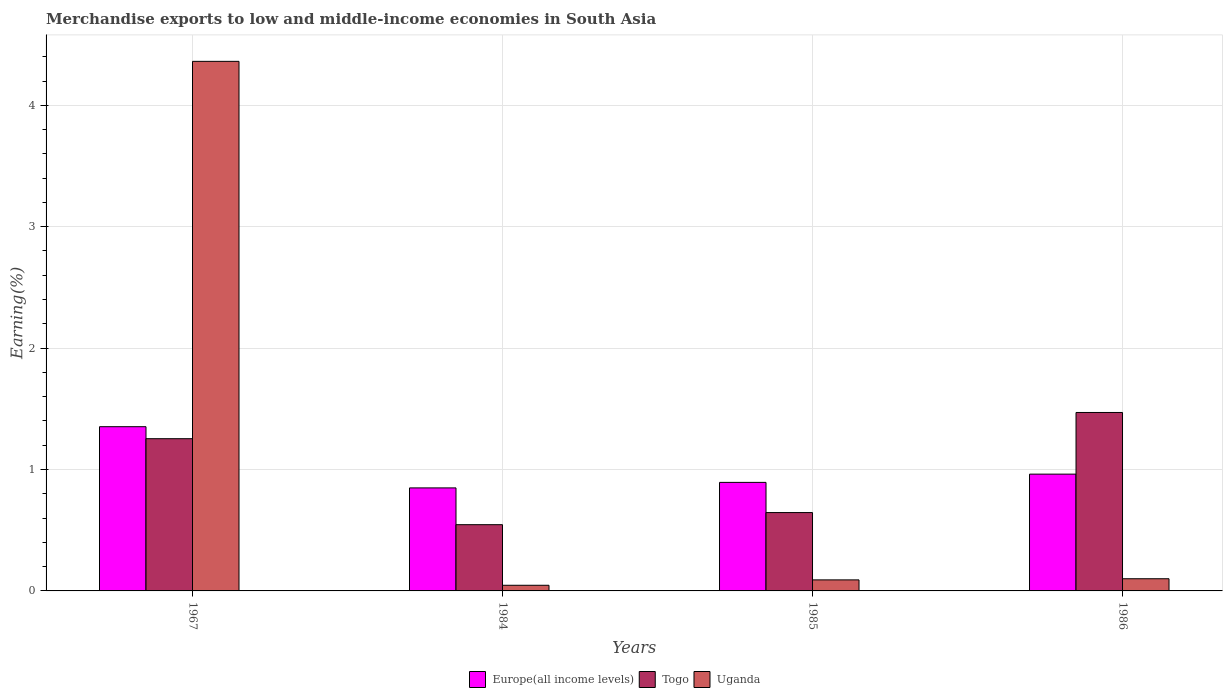How many different coloured bars are there?
Your response must be concise. 3. Are the number of bars on each tick of the X-axis equal?
Ensure brevity in your answer.  Yes. How many bars are there on the 1st tick from the right?
Provide a succinct answer. 3. What is the label of the 4th group of bars from the left?
Offer a very short reply. 1986. What is the percentage of amount earned from merchandise exports in Uganda in 1967?
Offer a terse response. 4.36. Across all years, what is the maximum percentage of amount earned from merchandise exports in Europe(all income levels)?
Offer a terse response. 1.35. Across all years, what is the minimum percentage of amount earned from merchandise exports in Europe(all income levels)?
Your answer should be very brief. 0.85. In which year was the percentage of amount earned from merchandise exports in Uganda maximum?
Your response must be concise. 1967. In which year was the percentage of amount earned from merchandise exports in Togo minimum?
Ensure brevity in your answer.  1984. What is the total percentage of amount earned from merchandise exports in Uganda in the graph?
Provide a succinct answer. 4.6. What is the difference between the percentage of amount earned from merchandise exports in Uganda in 1984 and that in 1986?
Give a very brief answer. -0.05. What is the difference between the percentage of amount earned from merchandise exports in Europe(all income levels) in 1986 and the percentage of amount earned from merchandise exports in Uganda in 1984?
Your answer should be compact. 0.92. What is the average percentage of amount earned from merchandise exports in Europe(all income levels) per year?
Offer a very short reply. 1.01. In the year 1967, what is the difference between the percentage of amount earned from merchandise exports in Togo and percentage of amount earned from merchandise exports in Europe(all income levels)?
Your response must be concise. -0.1. What is the ratio of the percentage of amount earned from merchandise exports in Uganda in 1984 to that in 1985?
Your answer should be very brief. 0.51. Is the percentage of amount earned from merchandise exports in Europe(all income levels) in 1967 less than that in 1985?
Keep it short and to the point. No. What is the difference between the highest and the second highest percentage of amount earned from merchandise exports in Uganda?
Provide a short and direct response. 4.26. What is the difference between the highest and the lowest percentage of amount earned from merchandise exports in Uganda?
Keep it short and to the point. 4.32. What does the 3rd bar from the left in 1967 represents?
Provide a succinct answer. Uganda. What does the 1st bar from the right in 1984 represents?
Offer a very short reply. Uganda. How many bars are there?
Provide a succinct answer. 12. Are all the bars in the graph horizontal?
Offer a very short reply. No. What is the difference between two consecutive major ticks on the Y-axis?
Keep it short and to the point. 1. Are the values on the major ticks of Y-axis written in scientific E-notation?
Your answer should be compact. No. Does the graph contain grids?
Keep it short and to the point. Yes. How many legend labels are there?
Make the answer very short. 3. What is the title of the graph?
Your answer should be compact. Merchandise exports to low and middle-income economies in South Asia. Does "Cameroon" appear as one of the legend labels in the graph?
Ensure brevity in your answer.  No. What is the label or title of the X-axis?
Offer a terse response. Years. What is the label or title of the Y-axis?
Give a very brief answer. Earning(%). What is the Earning(%) of Europe(all income levels) in 1967?
Ensure brevity in your answer.  1.35. What is the Earning(%) in Togo in 1967?
Give a very brief answer. 1.25. What is the Earning(%) of Uganda in 1967?
Give a very brief answer. 4.36. What is the Earning(%) in Europe(all income levels) in 1984?
Provide a short and direct response. 0.85. What is the Earning(%) of Togo in 1984?
Make the answer very short. 0.55. What is the Earning(%) of Uganda in 1984?
Offer a terse response. 0.05. What is the Earning(%) in Europe(all income levels) in 1985?
Your answer should be very brief. 0.89. What is the Earning(%) of Togo in 1985?
Provide a succinct answer. 0.65. What is the Earning(%) of Uganda in 1985?
Make the answer very short. 0.09. What is the Earning(%) in Europe(all income levels) in 1986?
Keep it short and to the point. 0.96. What is the Earning(%) in Togo in 1986?
Offer a terse response. 1.47. What is the Earning(%) in Uganda in 1986?
Provide a succinct answer. 0.1. Across all years, what is the maximum Earning(%) of Europe(all income levels)?
Offer a terse response. 1.35. Across all years, what is the maximum Earning(%) in Togo?
Offer a very short reply. 1.47. Across all years, what is the maximum Earning(%) in Uganda?
Make the answer very short. 4.36. Across all years, what is the minimum Earning(%) in Europe(all income levels)?
Make the answer very short. 0.85. Across all years, what is the minimum Earning(%) in Togo?
Provide a short and direct response. 0.55. Across all years, what is the minimum Earning(%) of Uganda?
Offer a terse response. 0.05. What is the total Earning(%) in Europe(all income levels) in the graph?
Provide a short and direct response. 4.06. What is the total Earning(%) of Togo in the graph?
Provide a short and direct response. 3.91. What is the total Earning(%) in Uganda in the graph?
Give a very brief answer. 4.6. What is the difference between the Earning(%) of Europe(all income levels) in 1967 and that in 1984?
Your response must be concise. 0.5. What is the difference between the Earning(%) in Togo in 1967 and that in 1984?
Your answer should be compact. 0.71. What is the difference between the Earning(%) of Uganda in 1967 and that in 1984?
Make the answer very short. 4.32. What is the difference between the Earning(%) in Europe(all income levels) in 1967 and that in 1985?
Ensure brevity in your answer.  0.46. What is the difference between the Earning(%) in Togo in 1967 and that in 1985?
Offer a terse response. 0.61. What is the difference between the Earning(%) of Uganda in 1967 and that in 1985?
Make the answer very short. 4.27. What is the difference between the Earning(%) in Europe(all income levels) in 1967 and that in 1986?
Your answer should be very brief. 0.39. What is the difference between the Earning(%) in Togo in 1967 and that in 1986?
Make the answer very short. -0.22. What is the difference between the Earning(%) in Uganda in 1967 and that in 1986?
Keep it short and to the point. 4.26. What is the difference between the Earning(%) in Europe(all income levels) in 1984 and that in 1985?
Your response must be concise. -0.05. What is the difference between the Earning(%) in Togo in 1984 and that in 1985?
Offer a very short reply. -0.1. What is the difference between the Earning(%) in Uganda in 1984 and that in 1985?
Offer a terse response. -0.04. What is the difference between the Earning(%) in Europe(all income levels) in 1984 and that in 1986?
Make the answer very short. -0.11. What is the difference between the Earning(%) of Togo in 1984 and that in 1986?
Your answer should be very brief. -0.92. What is the difference between the Earning(%) in Uganda in 1984 and that in 1986?
Give a very brief answer. -0.05. What is the difference between the Earning(%) in Europe(all income levels) in 1985 and that in 1986?
Your answer should be compact. -0.07. What is the difference between the Earning(%) of Togo in 1985 and that in 1986?
Provide a succinct answer. -0.82. What is the difference between the Earning(%) in Uganda in 1985 and that in 1986?
Your response must be concise. -0.01. What is the difference between the Earning(%) of Europe(all income levels) in 1967 and the Earning(%) of Togo in 1984?
Make the answer very short. 0.81. What is the difference between the Earning(%) in Europe(all income levels) in 1967 and the Earning(%) in Uganda in 1984?
Provide a short and direct response. 1.31. What is the difference between the Earning(%) of Togo in 1967 and the Earning(%) of Uganda in 1984?
Your answer should be very brief. 1.21. What is the difference between the Earning(%) of Europe(all income levels) in 1967 and the Earning(%) of Togo in 1985?
Give a very brief answer. 0.71. What is the difference between the Earning(%) in Europe(all income levels) in 1967 and the Earning(%) in Uganda in 1985?
Provide a succinct answer. 1.26. What is the difference between the Earning(%) in Togo in 1967 and the Earning(%) in Uganda in 1985?
Offer a terse response. 1.16. What is the difference between the Earning(%) of Europe(all income levels) in 1967 and the Earning(%) of Togo in 1986?
Your answer should be compact. -0.12. What is the difference between the Earning(%) of Europe(all income levels) in 1967 and the Earning(%) of Uganda in 1986?
Offer a terse response. 1.25. What is the difference between the Earning(%) of Togo in 1967 and the Earning(%) of Uganda in 1986?
Provide a short and direct response. 1.15. What is the difference between the Earning(%) in Europe(all income levels) in 1984 and the Earning(%) in Togo in 1985?
Ensure brevity in your answer.  0.2. What is the difference between the Earning(%) in Europe(all income levels) in 1984 and the Earning(%) in Uganda in 1985?
Your response must be concise. 0.76. What is the difference between the Earning(%) in Togo in 1984 and the Earning(%) in Uganda in 1985?
Your answer should be very brief. 0.45. What is the difference between the Earning(%) of Europe(all income levels) in 1984 and the Earning(%) of Togo in 1986?
Your answer should be very brief. -0.62. What is the difference between the Earning(%) of Europe(all income levels) in 1984 and the Earning(%) of Uganda in 1986?
Your answer should be very brief. 0.75. What is the difference between the Earning(%) of Togo in 1984 and the Earning(%) of Uganda in 1986?
Your answer should be compact. 0.45. What is the difference between the Earning(%) in Europe(all income levels) in 1985 and the Earning(%) in Togo in 1986?
Offer a terse response. -0.58. What is the difference between the Earning(%) in Europe(all income levels) in 1985 and the Earning(%) in Uganda in 1986?
Your answer should be compact. 0.79. What is the difference between the Earning(%) of Togo in 1985 and the Earning(%) of Uganda in 1986?
Keep it short and to the point. 0.55. What is the average Earning(%) in Europe(all income levels) per year?
Provide a short and direct response. 1.01. What is the average Earning(%) of Togo per year?
Your answer should be compact. 0.98. What is the average Earning(%) of Uganda per year?
Your answer should be very brief. 1.15. In the year 1967, what is the difference between the Earning(%) in Europe(all income levels) and Earning(%) in Togo?
Provide a short and direct response. 0.1. In the year 1967, what is the difference between the Earning(%) of Europe(all income levels) and Earning(%) of Uganda?
Offer a terse response. -3.01. In the year 1967, what is the difference between the Earning(%) of Togo and Earning(%) of Uganda?
Your answer should be very brief. -3.11. In the year 1984, what is the difference between the Earning(%) of Europe(all income levels) and Earning(%) of Togo?
Provide a succinct answer. 0.3. In the year 1984, what is the difference between the Earning(%) in Europe(all income levels) and Earning(%) in Uganda?
Provide a succinct answer. 0.8. In the year 1984, what is the difference between the Earning(%) in Togo and Earning(%) in Uganda?
Your answer should be compact. 0.5. In the year 1985, what is the difference between the Earning(%) of Europe(all income levels) and Earning(%) of Togo?
Offer a very short reply. 0.25. In the year 1985, what is the difference between the Earning(%) in Europe(all income levels) and Earning(%) in Uganda?
Provide a succinct answer. 0.8. In the year 1985, what is the difference between the Earning(%) of Togo and Earning(%) of Uganda?
Your response must be concise. 0.55. In the year 1986, what is the difference between the Earning(%) of Europe(all income levels) and Earning(%) of Togo?
Your response must be concise. -0.51. In the year 1986, what is the difference between the Earning(%) in Europe(all income levels) and Earning(%) in Uganda?
Your answer should be very brief. 0.86. In the year 1986, what is the difference between the Earning(%) in Togo and Earning(%) in Uganda?
Provide a short and direct response. 1.37. What is the ratio of the Earning(%) in Europe(all income levels) in 1967 to that in 1984?
Offer a terse response. 1.59. What is the ratio of the Earning(%) of Togo in 1967 to that in 1984?
Ensure brevity in your answer.  2.3. What is the ratio of the Earning(%) of Uganda in 1967 to that in 1984?
Your answer should be very brief. 93.64. What is the ratio of the Earning(%) of Europe(all income levels) in 1967 to that in 1985?
Your answer should be compact. 1.51. What is the ratio of the Earning(%) in Togo in 1967 to that in 1985?
Offer a terse response. 1.94. What is the ratio of the Earning(%) in Uganda in 1967 to that in 1985?
Provide a succinct answer. 47.97. What is the ratio of the Earning(%) of Europe(all income levels) in 1967 to that in 1986?
Your answer should be compact. 1.41. What is the ratio of the Earning(%) in Togo in 1967 to that in 1986?
Your answer should be compact. 0.85. What is the ratio of the Earning(%) in Uganda in 1967 to that in 1986?
Keep it short and to the point. 43.48. What is the ratio of the Earning(%) in Europe(all income levels) in 1984 to that in 1985?
Offer a terse response. 0.95. What is the ratio of the Earning(%) in Togo in 1984 to that in 1985?
Ensure brevity in your answer.  0.85. What is the ratio of the Earning(%) in Uganda in 1984 to that in 1985?
Offer a very short reply. 0.51. What is the ratio of the Earning(%) of Europe(all income levels) in 1984 to that in 1986?
Offer a very short reply. 0.88. What is the ratio of the Earning(%) of Togo in 1984 to that in 1986?
Your response must be concise. 0.37. What is the ratio of the Earning(%) in Uganda in 1984 to that in 1986?
Provide a short and direct response. 0.46. What is the ratio of the Earning(%) of Europe(all income levels) in 1985 to that in 1986?
Your answer should be very brief. 0.93. What is the ratio of the Earning(%) of Togo in 1985 to that in 1986?
Provide a succinct answer. 0.44. What is the ratio of the Earning(%) of Uganda in 1985 to that in 1986?
Your answer should be very brief. 0.91. What is the difference between the highest and the second highest Earning(%) of Europe(all income levels)?
Provide a short and direct response. 0.39. What is the difference between the highest and the second highest Earning(%) of Togo?
Provide a short and direct response. 0.22. What is the difference between the highest and the second highest Earning(%) in Uganda?
Provide a succinct answer. 4.26. What is the difference between the highest and the lowest Earning(%) in Europe(all income levels)?
Offer a terse response. 0.5. What is the difference between the highest and the lowest Earning(%) in Togo?
Ensure brevity in your answer.  0.92. What is the difference between the highest and the lowest Earning(%) in Uganda?
Give a very brief answer. 4.32. 